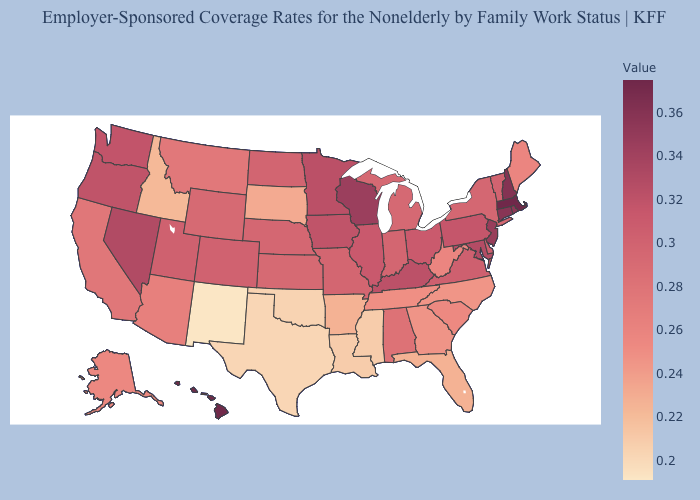Among the states that border Mississippi , does Louisiana have the lowest value?
Answer briefly. Yes. Which states have the lowest value in the West?
Quick response, please. New Mexico. Does Florida have a lower value than New Mexico?
Answer briefly. No. Does the map have missing data?
Quick response, please. No. Which states have the lowest value in the South?
Write a very short answer. Texas. Does Vermont have the lowest value in the USA?
Quick response, please. No. Does Oregon have the highest value in the USA?
Write a very short answer. No. Is the legend a continuous bar?
Give a very brief answer. Yes. Does North Dakota have a lower value than Montana?
Answer briefly. No. 